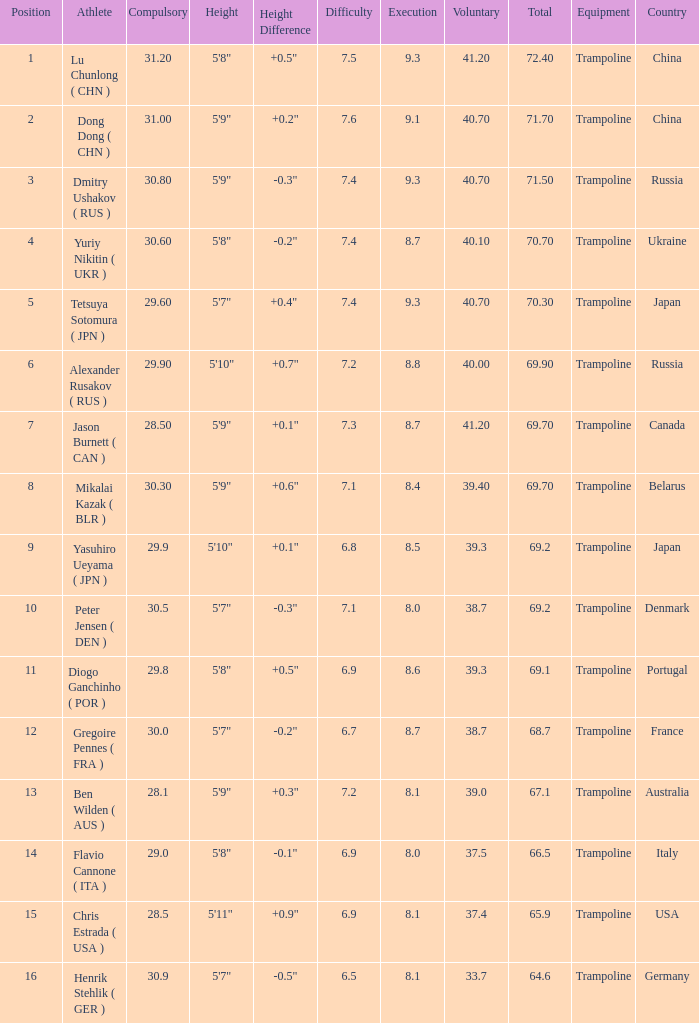What's the position that has a total less than 66.5m, a compulsory of 30.9 and voluntary less than 33.7? None. 